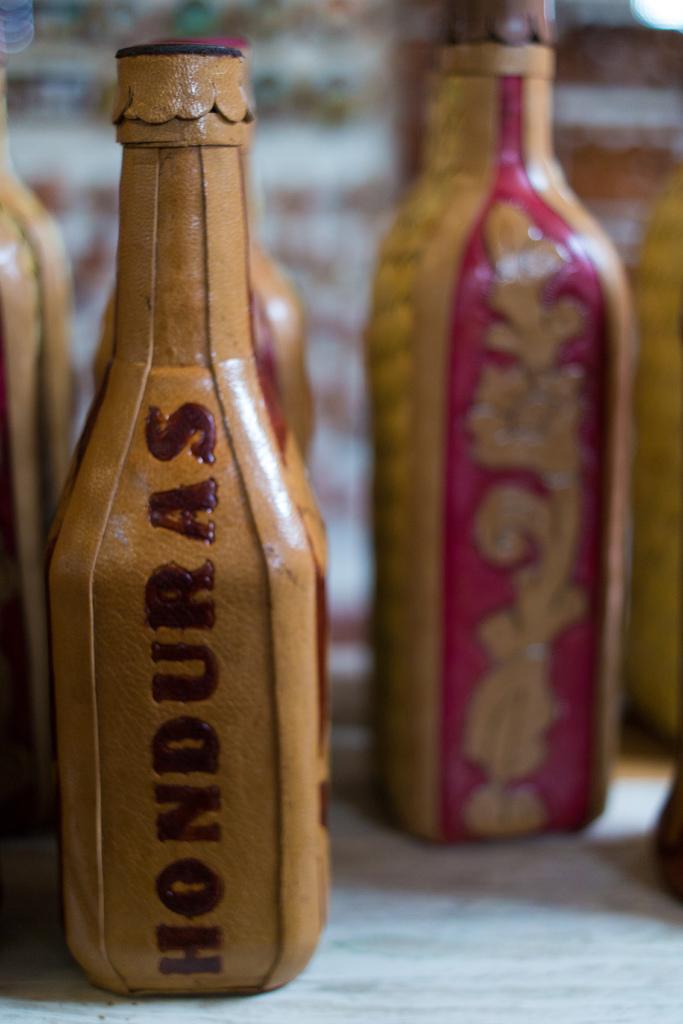Where is this bottle from?
Provide a succinct answer. Honduras. 